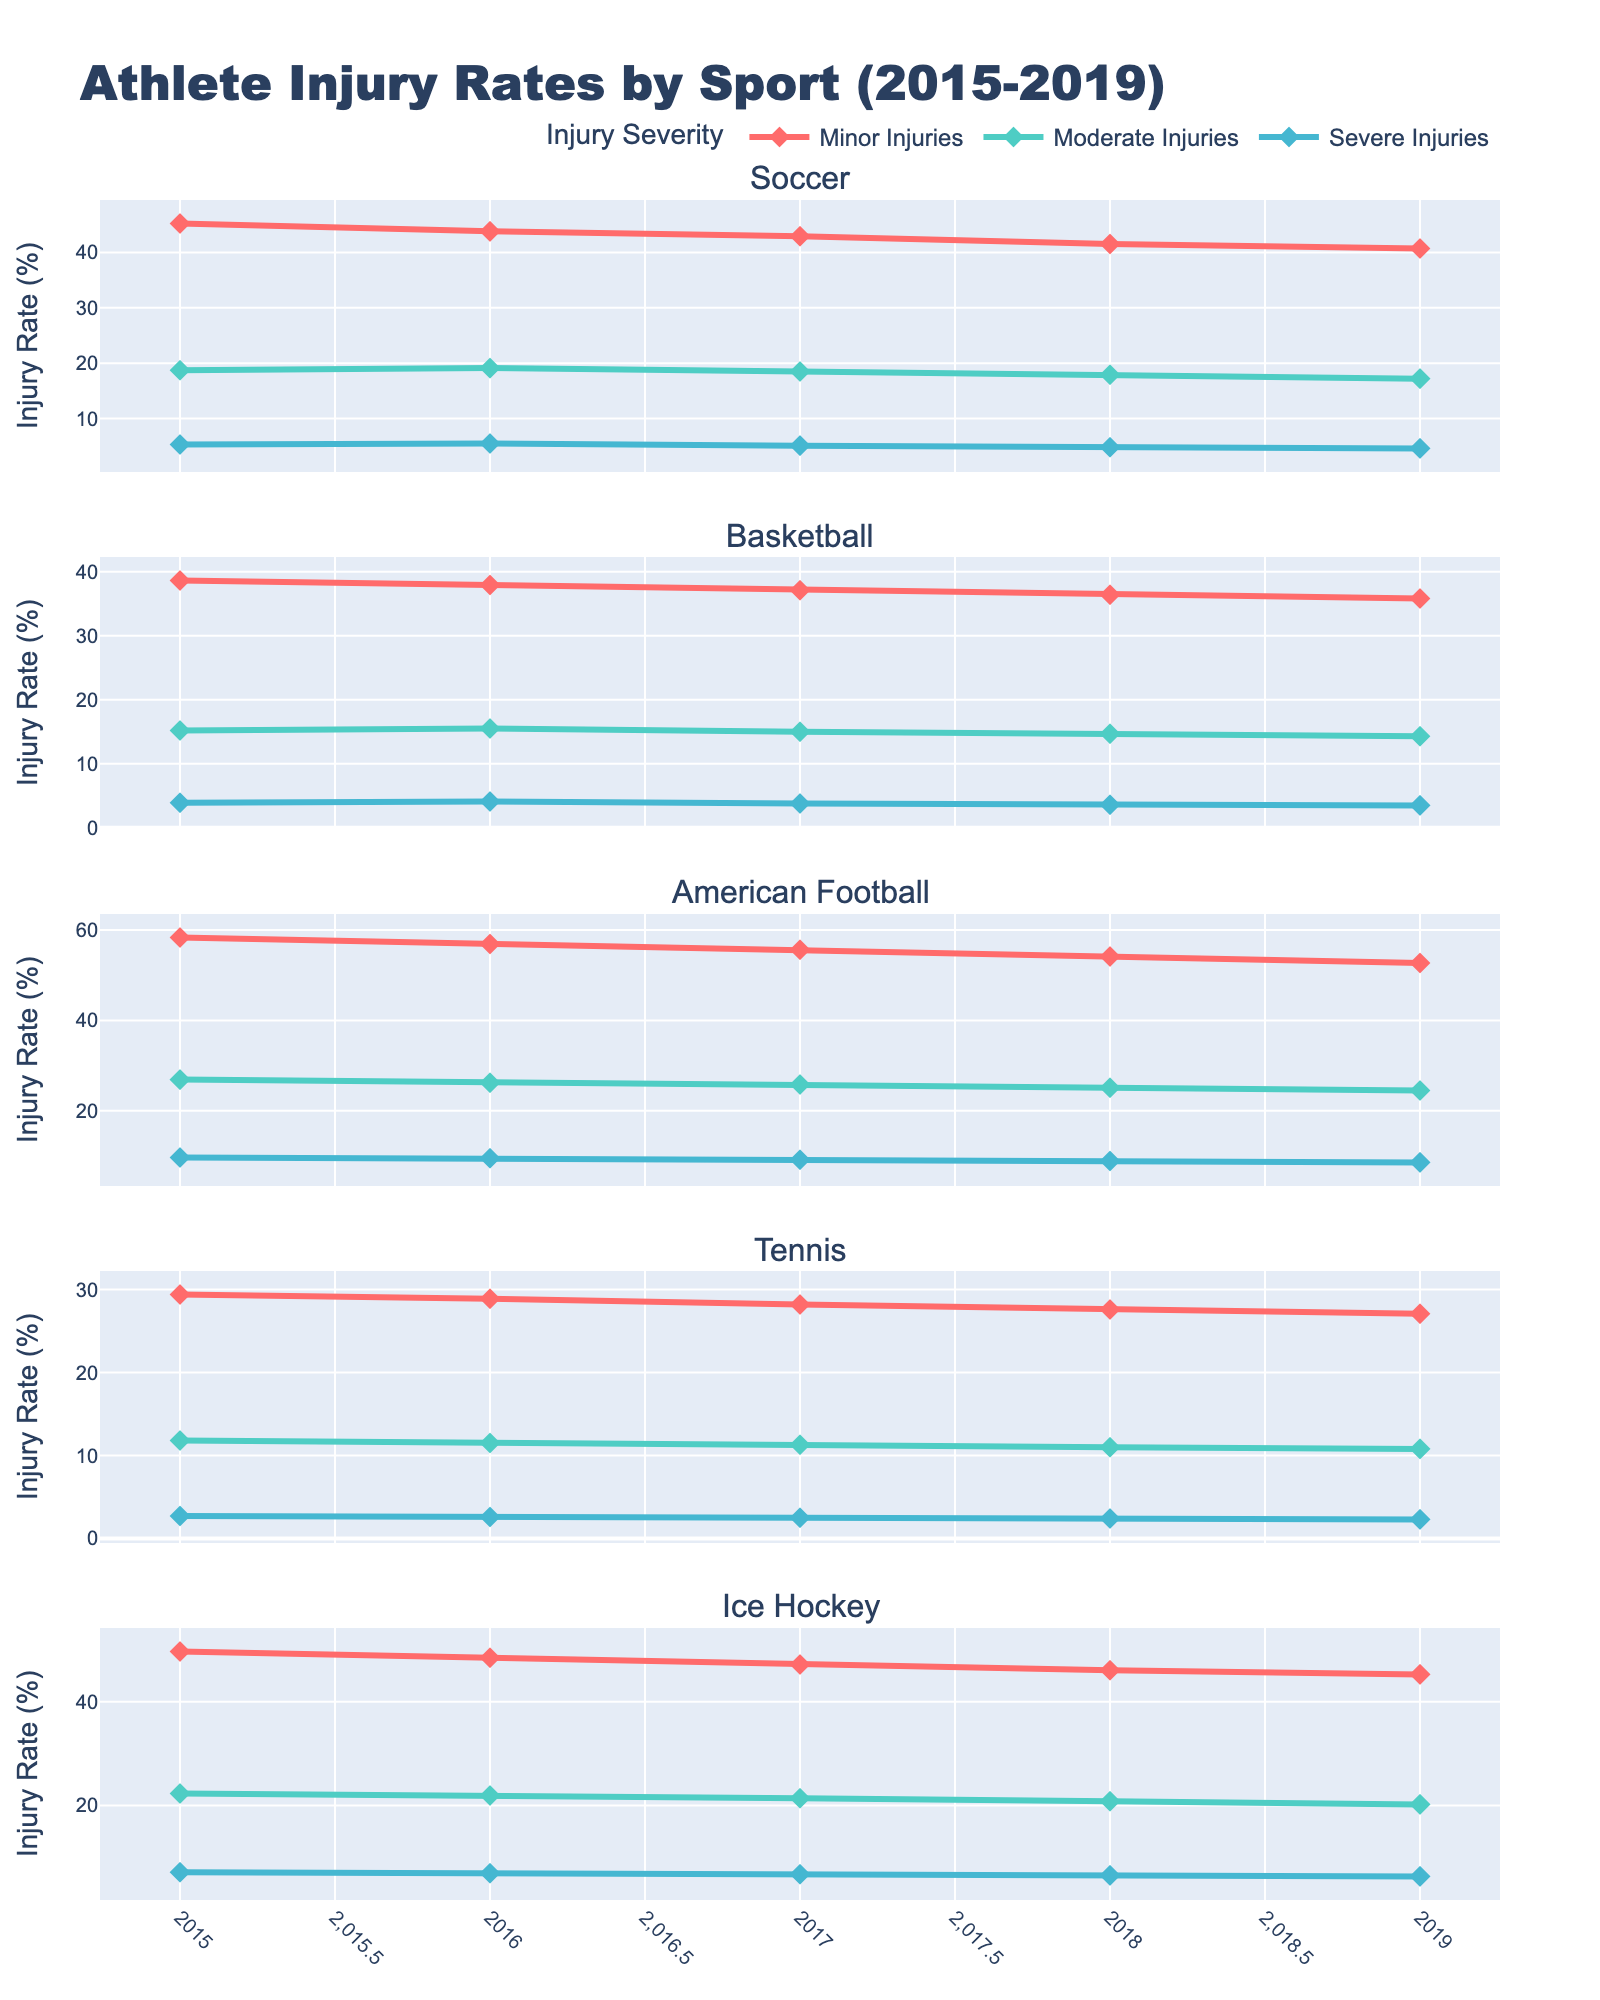How does the rate of minor injuries in Tennis in 2019 compare to that in 2015? To identify the rate of minor injuries in Tennis in 2015 and compare it to 2019, locate the respective data points on the x-axis. The 2015 value is 29.4%, and for 2019, it's 27.1%. Comparing these shows a decline.
Answer: There is a decline Which sport recorded the highest percentage of minor injuries in 2017? Look at the data points along the y-axis for all sports in 2017. The highest value is observed for American Football, which recorded 55.6% minor injuries.
Answer: American Football By how much did severe injuries in Ice Hockey decrease from 2015 to 2019? First, find the rate of severe injuries in Ice Hockey for both years. The values are 7.1% in 2015 and 6.3% in 2019. Subtract 6.3 from 7.1 to get the decrease.
Answer: 0.8% What is the average rate of moderate injuries in Basketball from 2015 to 2019? Sum the moderate injury rates for all years for Basketball (15.2%, 15.5%, 15.0%, 14.7%, 14.3%) and divide by the number of years (5). The total is 74.7%, so the average is 74.7 / 5 = 14.94%.
Answer: 14.94% Which sport had the most significant decrease in minor injury rates over the observed period? Compare the rate of minor injuries from 2015 to 2019 for all sports. Soccer decreased from 45.2% to 40.7% (4.5%), Basketball from 38.6% to 35.8% (2.8%), American Football from 58.3% to 52.7% (5.6%), Tennis from 29.4% to 27.1% (2.3%), and Ice Hockey from 49.7% to 45.3% (4.4%). The most significant decrease is in American Football.
Answer: American Football In which year did American Football have the lowest rate of severe injuries, and what was the rate? Locate the severe injuries line for American Football and find the lowest point. It is in 2019 with 8.6%.
Answer: 2019, 8.6% Comparing moderate injuries in Soccer and American Football in 2018, which had a higher rate, and by how much? Find moderate injury rates for both sports in 2018: Soccer had 17.9% and American Football had 25.1%. Subtract 17.9 from 25.1 to determine the difference.
Answer: American Football, 7.2% higher What trend can be observed for minor injuries in Ice Hockey from 2015 to 2019? Observe the line representing minor injuries in Ice Hockey. It shows a downward trend, decreasing from 49.7% in 2015 to 45.3% in 2019.
Answer: Downward trend How do moderate injury rates in Tennis in 2016 and 2018 compare? Find the moderate injury rates for Tennis in 2016 (11.5%) and 2018 (11.0%). Compare these values to see a decrease.
Answer: Decreased What is the difference in minor injury rates between Soccer and Basketball in 2017? Check the minor injury rates for Soccer (42.9%) and Basketball (37.1%) in 2017. Subtract 37.1 from 42.9 to find the difference.
Answer: 5.8% 